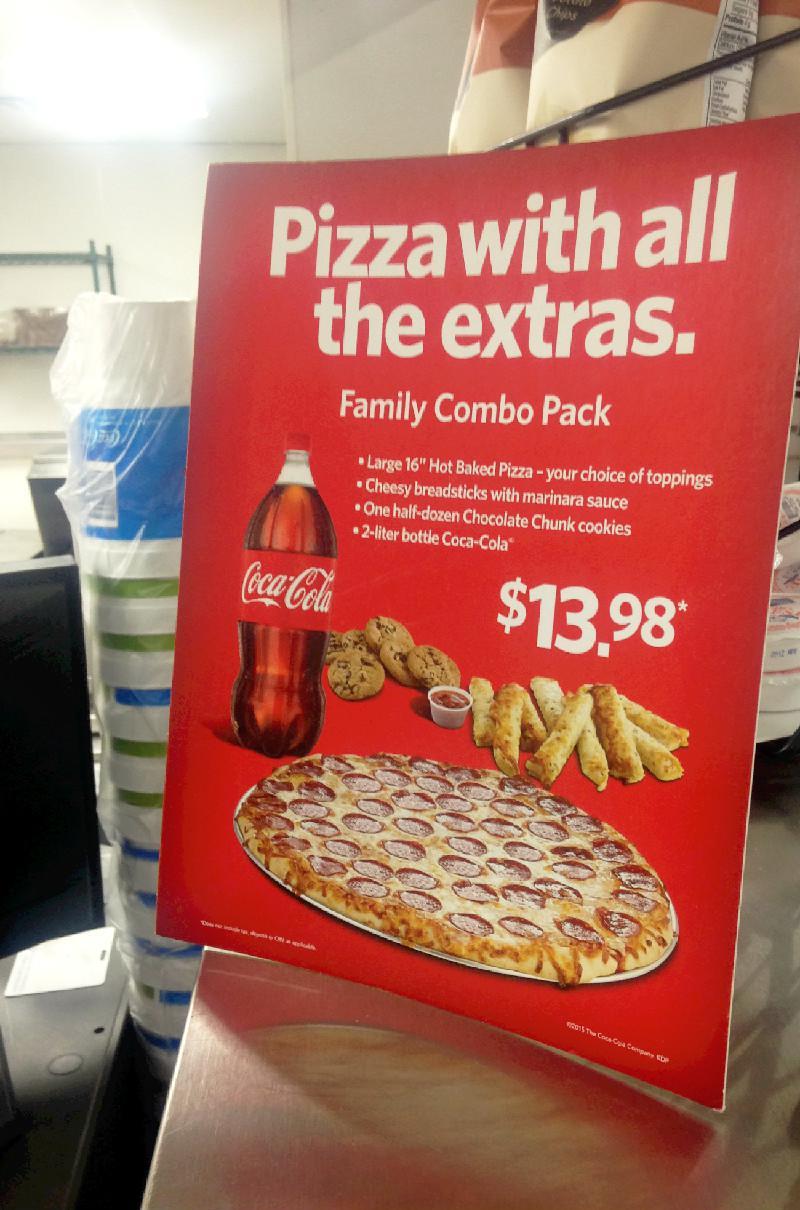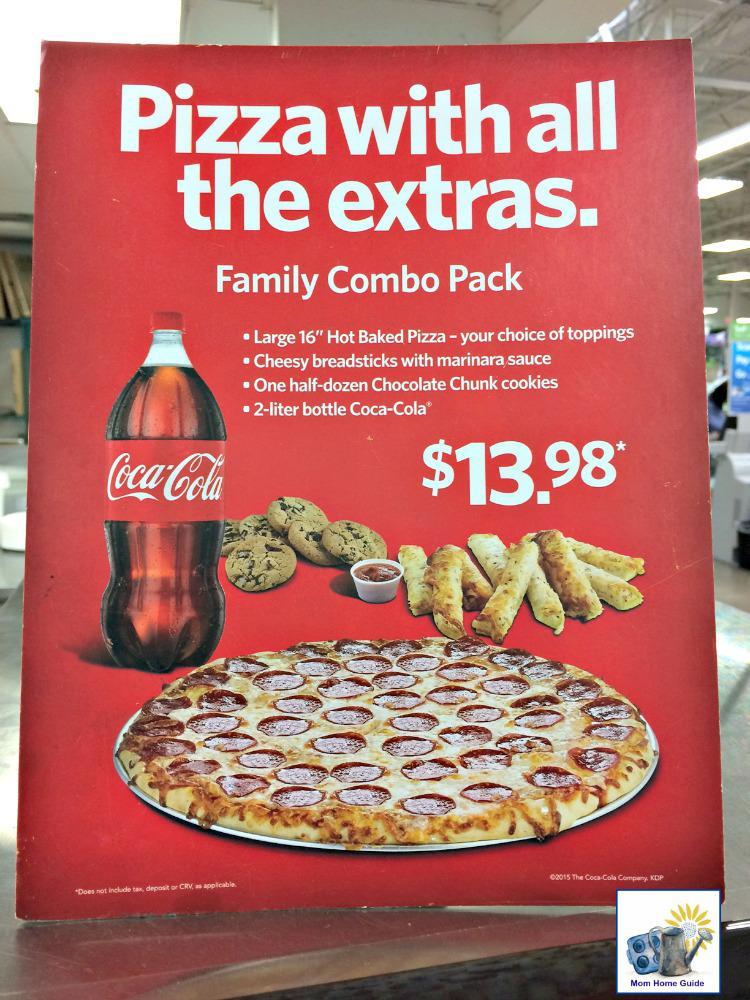The first image is the image on the left, the second image is the image on the right. For the images displayed, is the sentence "The left image includes a pizza in an open box, a plate containing a row of cheesy bread with a container of red sauce next to it, a plate of cookies, and a bottle of cola beside the pizza box." factually correct? Answer yes or no. No. 